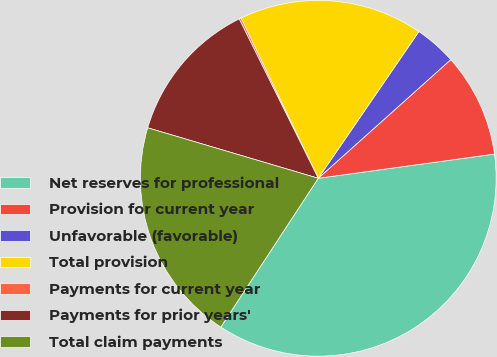Convert chart. <chart><loc_0><loc_0><loc_500><loc_500><pie_chart><fcel>Net reserves for professional<fcel>Provision for current year<fcel>Unfavorable (favorable)<fcel>Total provision<fcel>Payments for current year<fcel>Payments for prior years'<fcel>Total claim payments<nl><fcel>36.4%<fcel>9.45%<fcel>3.81%<fcel>16.72%<fcel>0.18%<fcel>13.09%<fcel>20.35%<nl></chart> 